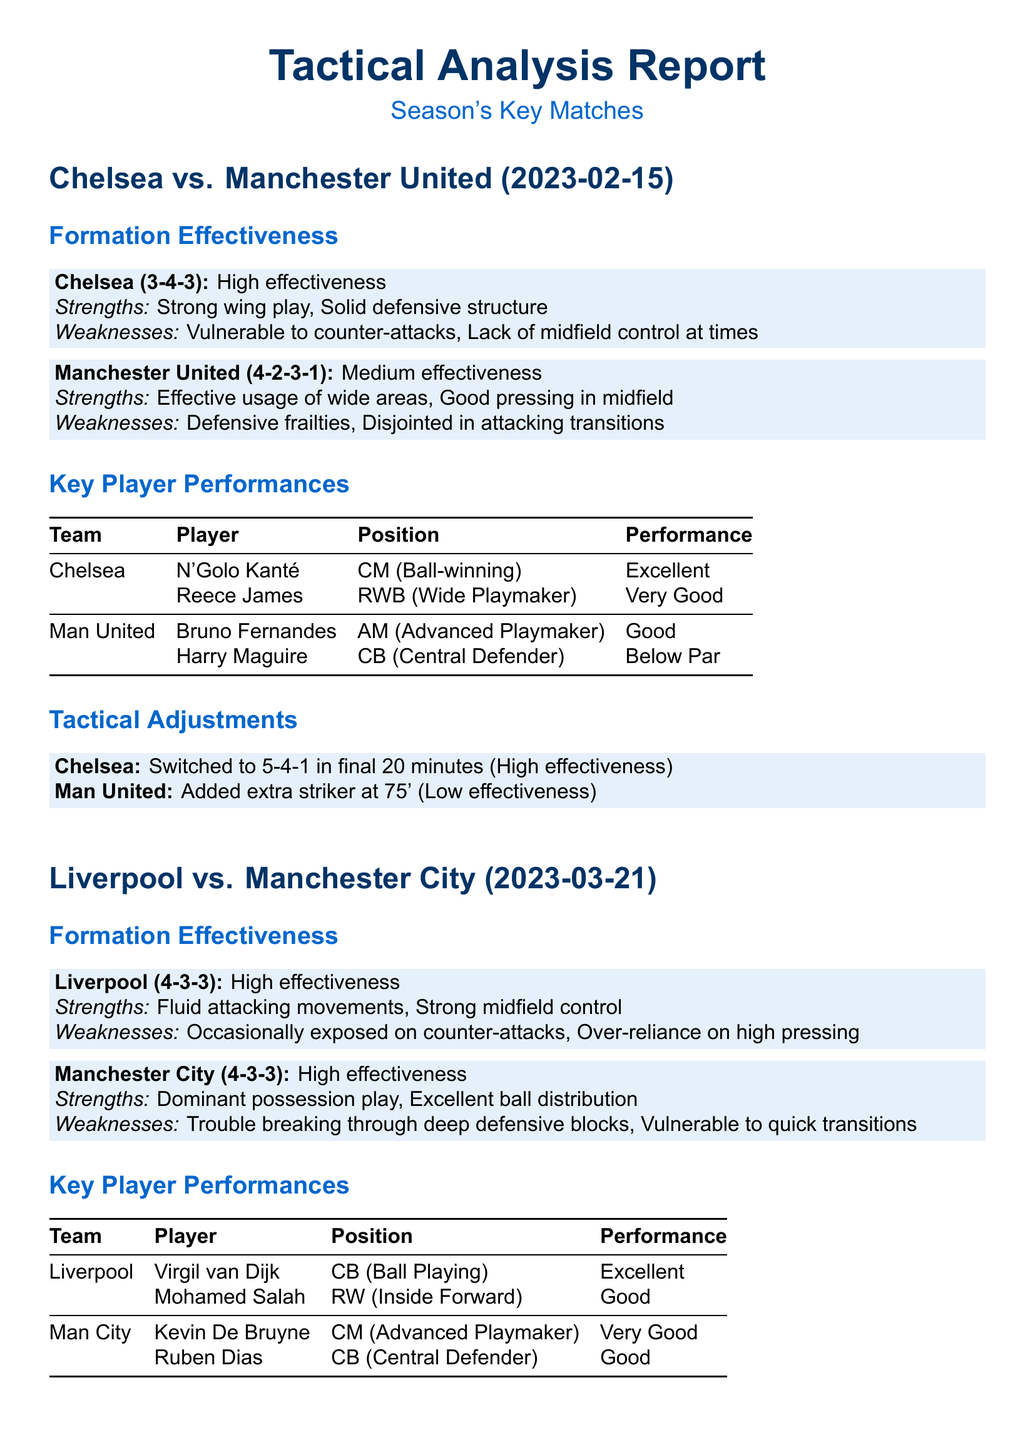What was Chelsea's formation against Manchester United? Chelsea played in a 3-4-3 formation during the match against Manchester United.
Answer: 3-4-3 What was Manchester United's key weakness in their formation? The report states that Manchester United's key weakness was their defensive frailties.
Answer: Defensive frailties Who was the player with the best performance for Chelsea? N'Golo Kanté had an excellent performance in the match, as noted in the report.
Answer: Excellent Which tactical adjustment did Chelsea make towards the end of the match against Manchester United? Chelsea switched to a 5-4-1 formation in the final moments of the game.
Answer: 5-4-1 What strength did Liverpool exhibit in their match against Manchester City? Liverpool exhibited fluid attacking movements as one of their strengths.
Answer: Fluid attacking movements How effective was Man City's tactical adjustment of pushing full-backs up in the second half? The effectiveness of pushing full-backs up was classified as high effectiveness in the report.
Answer: High effectiveness What was the positioning of Reece James in the match? Reece James played as a right wing-back (RWB) during the match against Manchester United.
Answer: RWB What was the final tactical adjustment made by Liverpool in the last 10 minutes? Liverpool switched to a 4-5-1 formation in the last moments of the match.
Answer: 4-5-1 What was the performance rating of Bruno Fernandes in the match? Bruno Fernandes had a good performance rating in their match against Chelsea.
Answer: Good 